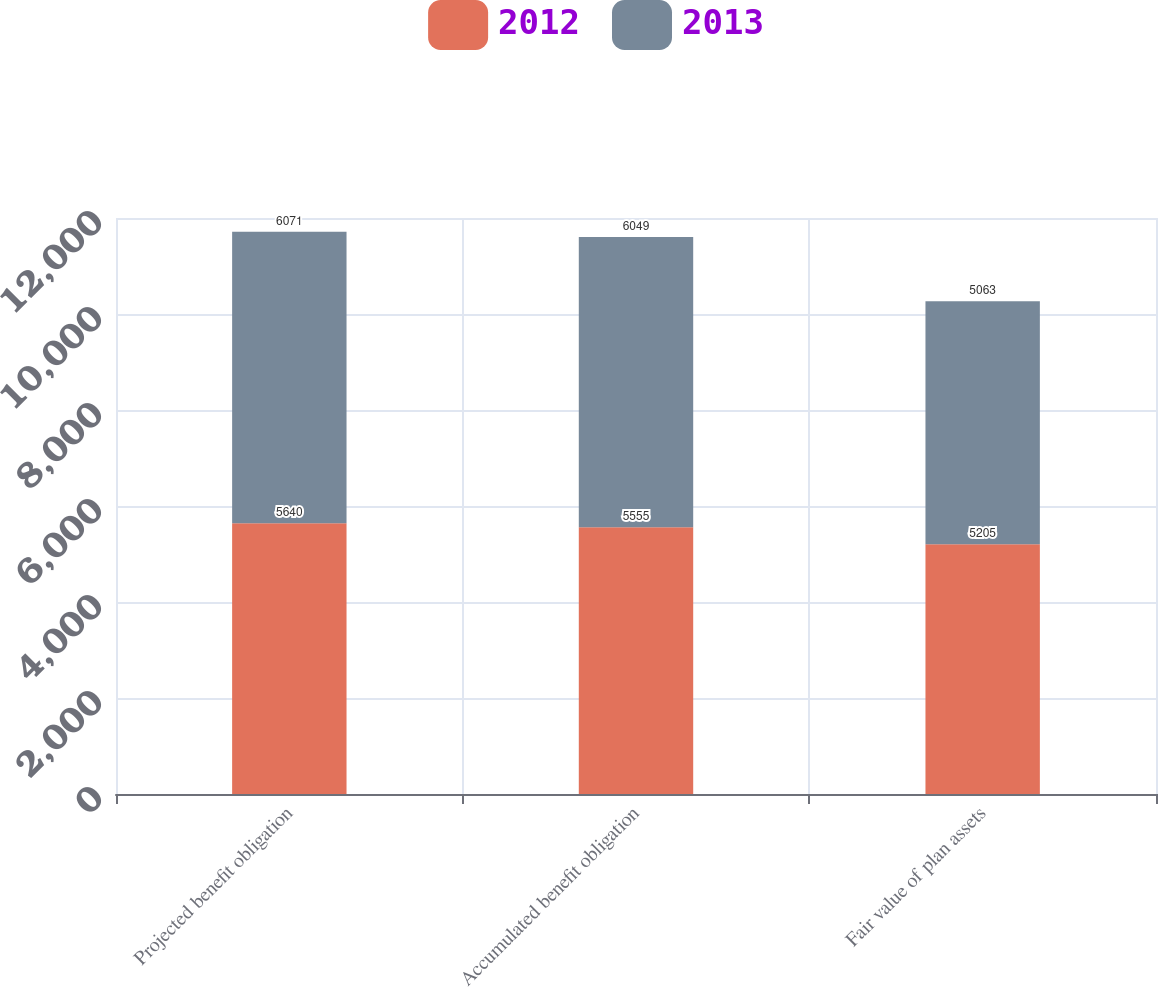Convert chart to OTSL. <chart><loc_0><loc_0><loc_500><loc_500><stacked_bar_chart><ecel><fcel>Projected benefit obligation<fcel>Accumulated benefit obligation<fcel>Fair value of plan assets<nl><fcel>2012<fcel>5640<fcel>5555<fcel>5205<nl><fcel>2013<fcel>6071<fcel>6049<fcel>5063<nl></chart> 